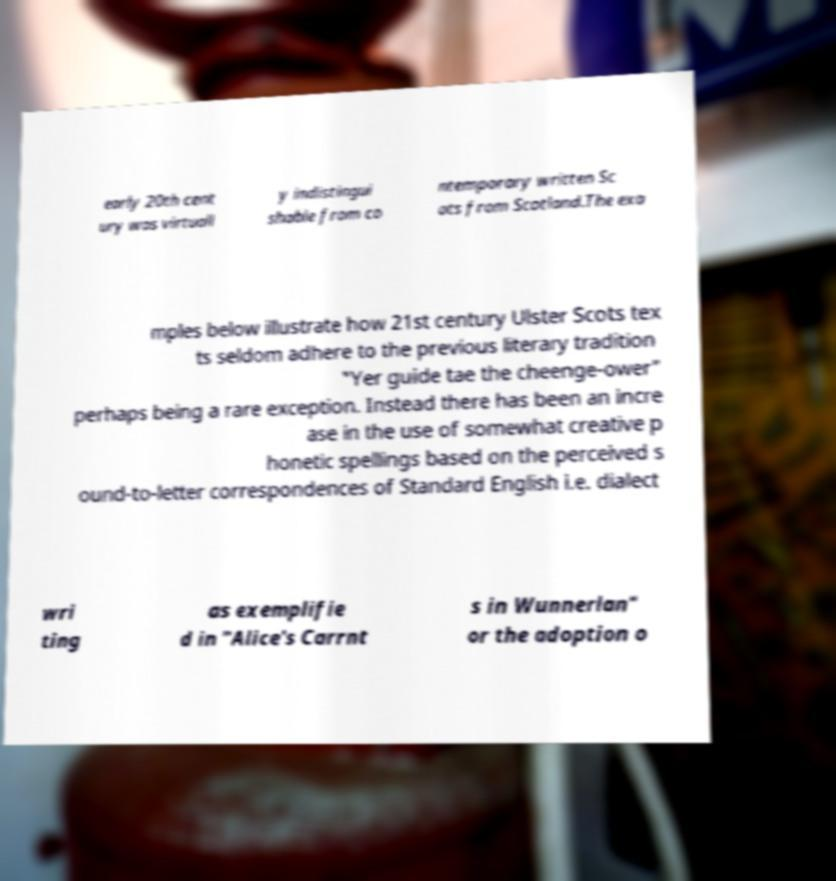For documentation purposes, I need the text within this image transcribed. Could you provide that? early 20th cent ury was virtuall y indistingui shable from co ntemporary written Sc ots from Scotland.The exa mples below illustrate how 21st century Ulster Scots tex ts seldom adhere to the previous literary tradition "Yer guide tae the cheenge-ower" perhaps being a rare exception. Instead there has been an incre ase in the use of somewhat creative p honetic spellings based on the perceived s ound-to-letter correspondences of Standard English i.e. dialect wri ting as exemplifie d in "Alice's Carrnt s in Wunnerlan" or the adoption o 